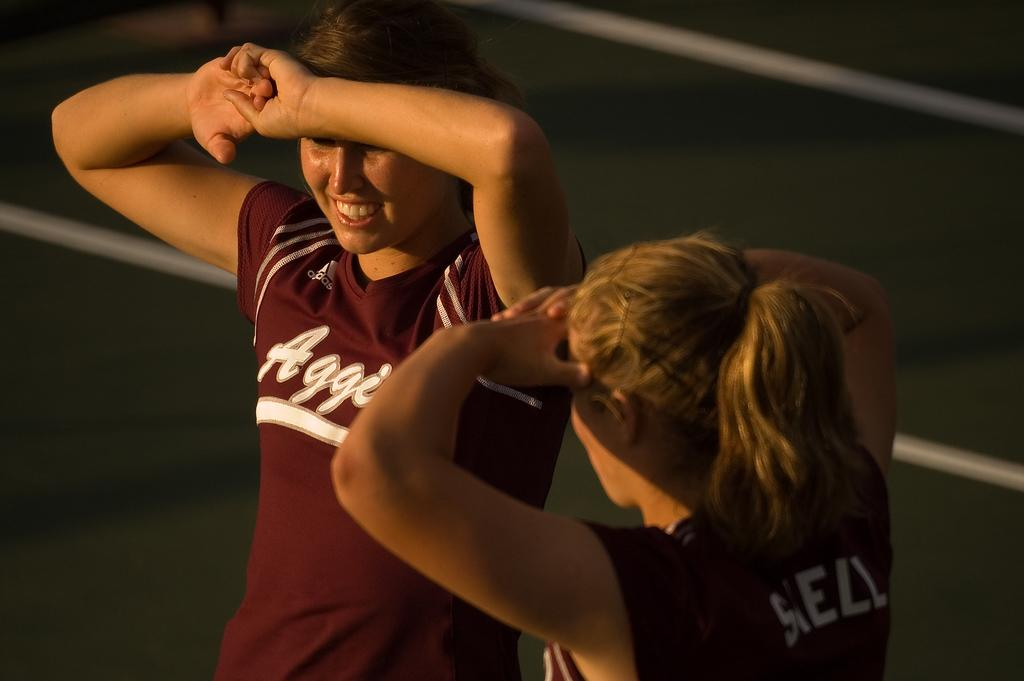<image>
Present a compact description of the photo's key features. Two girls wearing Aggies jerseys stand in the sun. 